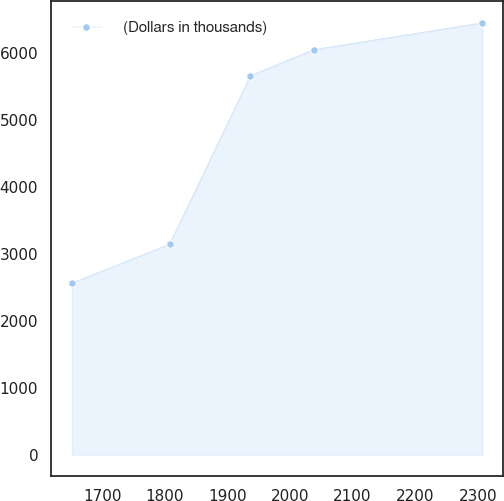<chart> <loc_0><loc_0><loc_500><loc_500><line_chart><ecel><fcel>(Dollars in thousands)<nl><fcel>1651.74<fcel>2566.7<nl><fcel>1807.66<fcel>3144.15<nl><fcel>1936.78<fcel>5663.55<nl><fcel>2037.67<fcel>6052.14<nl><fcel>2307.34<fcel>6452.57<nl></chart> 